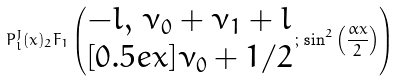<formula> <loc_0><loc_0><loc_500><loc_500>P ^ { J } _ { l } ( x ) _ { 2 } F _ { 1 } \left ( \begin{matrix} - l , \, \nu _ { 0 } + \nu _ { 1 } + l \\ [ 0 . 5 e x ] \nu _ { 0 } + 1 / 2 \end{matrix} \, ; \, \sin ^ { 2 } \left ( \frac { \alpha x } { 2 } \right ) \right )</formula> 